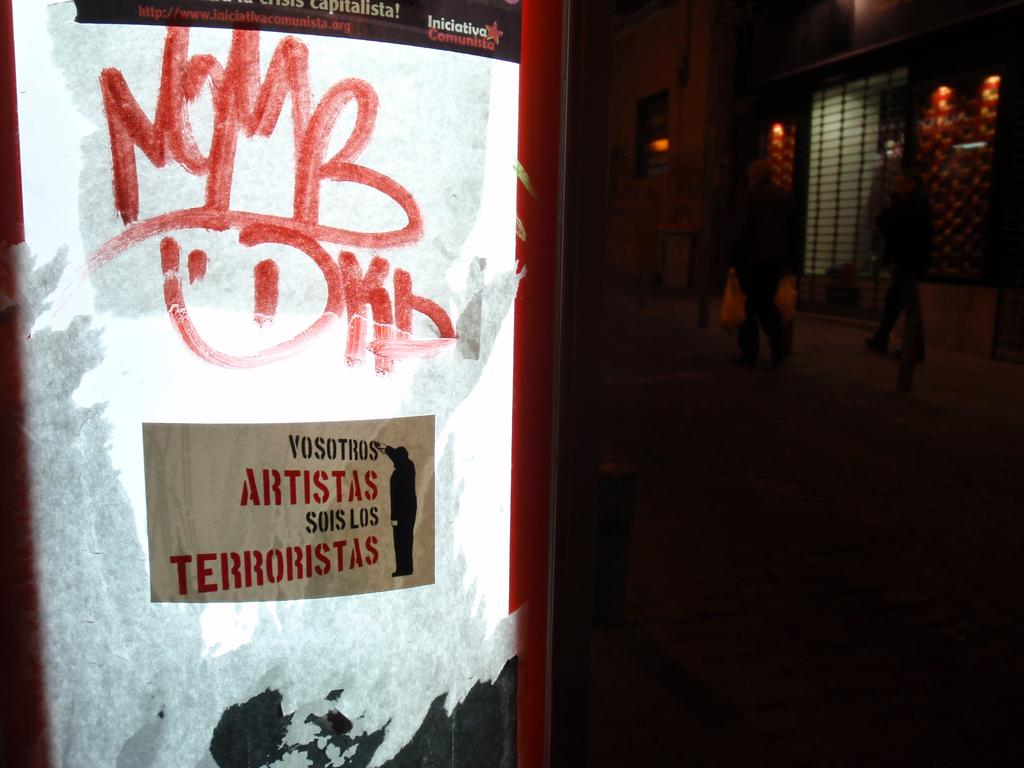<image>
Summarize the visual content of the image. A spanish sign that says Vosotros Artistas sois los terroristas. 